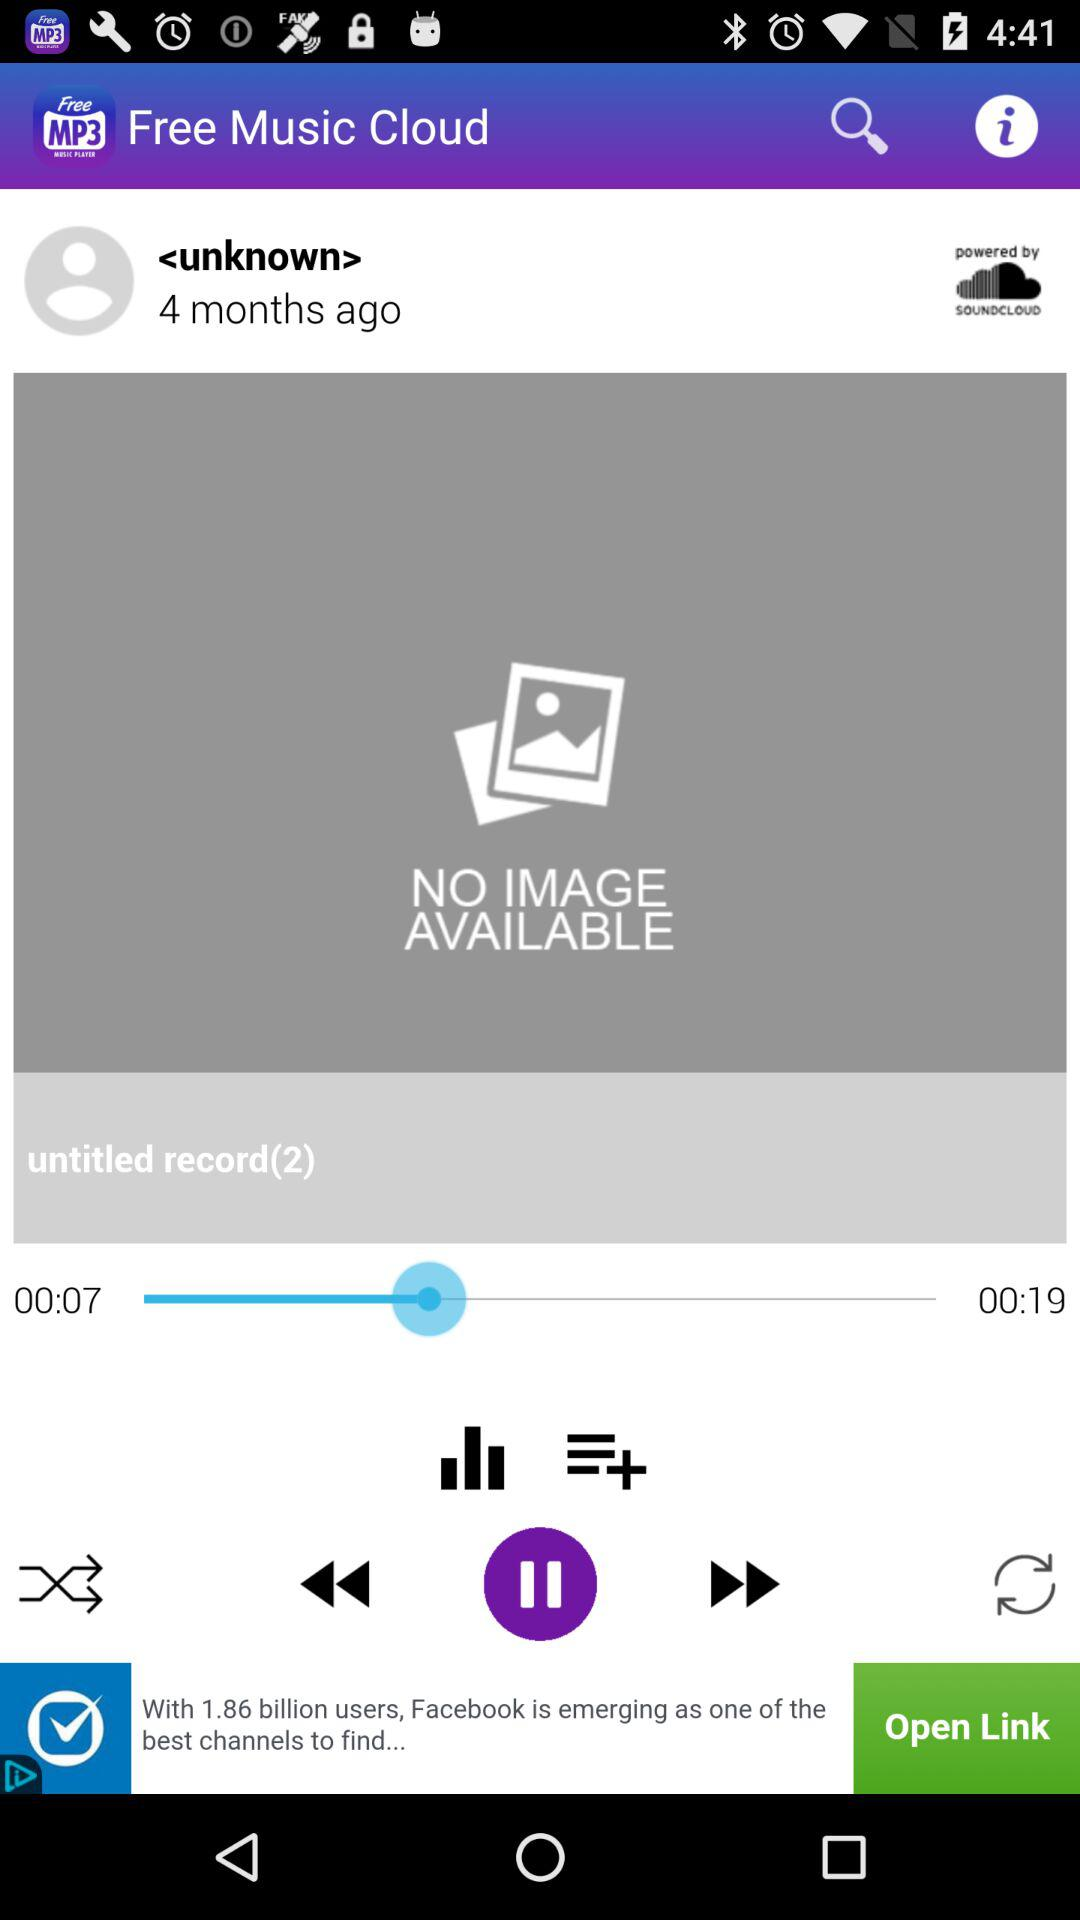Can you describe the layout and user interface colors used in the app? The app interface follows a simple layout with a focus on functionality. The primary color is purple, used in the top bar and the play/pause button, while the background is a neutral gray. Icons are minimalist and white, offering a clean aesthetic against the darker colors. 